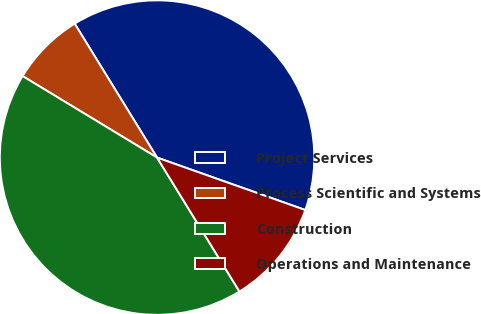Convert chart. <chart><loc_0><loc_0><loc_500><loc_500><pie_chart><fcel>Project Services<fcel>Process Scientific and Systems<fcel>Construction<fcel>Operations and Maintenance<nl><fcel>39.19%<fcel>7.55%<fcel>42.45%<fcel>10.81%<nl></chart> 